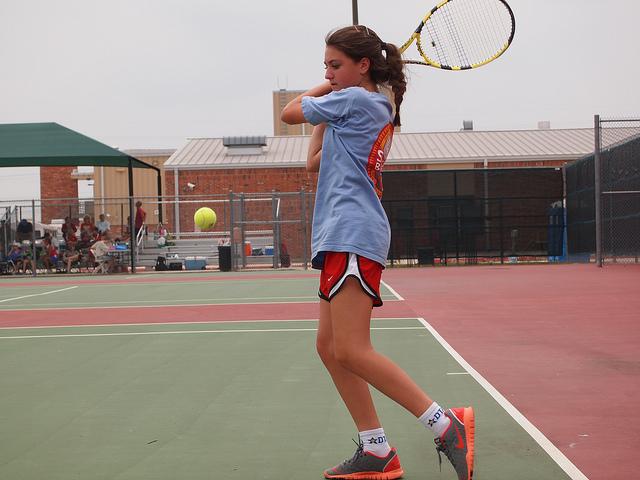Is cup.com an appropriate website address for this image?
Be succinct. No. Are they playing on clay?
Give a very brief answer. No. What color is the tennis player's ponytail holder?
Answer briefly. Black. What brand of shoes is this girl wearing?
Be succinct. Nike. What's the weather like at this tennis game?
Quick response, please. Cloudy. What color is the girls shirt?
Write a very short answer. Blue. What is the name of this tournament?
Short answer required. Tennis. What color are the man's shoelaces?
Concise answer only. Gray. What is behind the fence?
Give a very brief answer. Building. What color is the line?
Be succinct. White. 